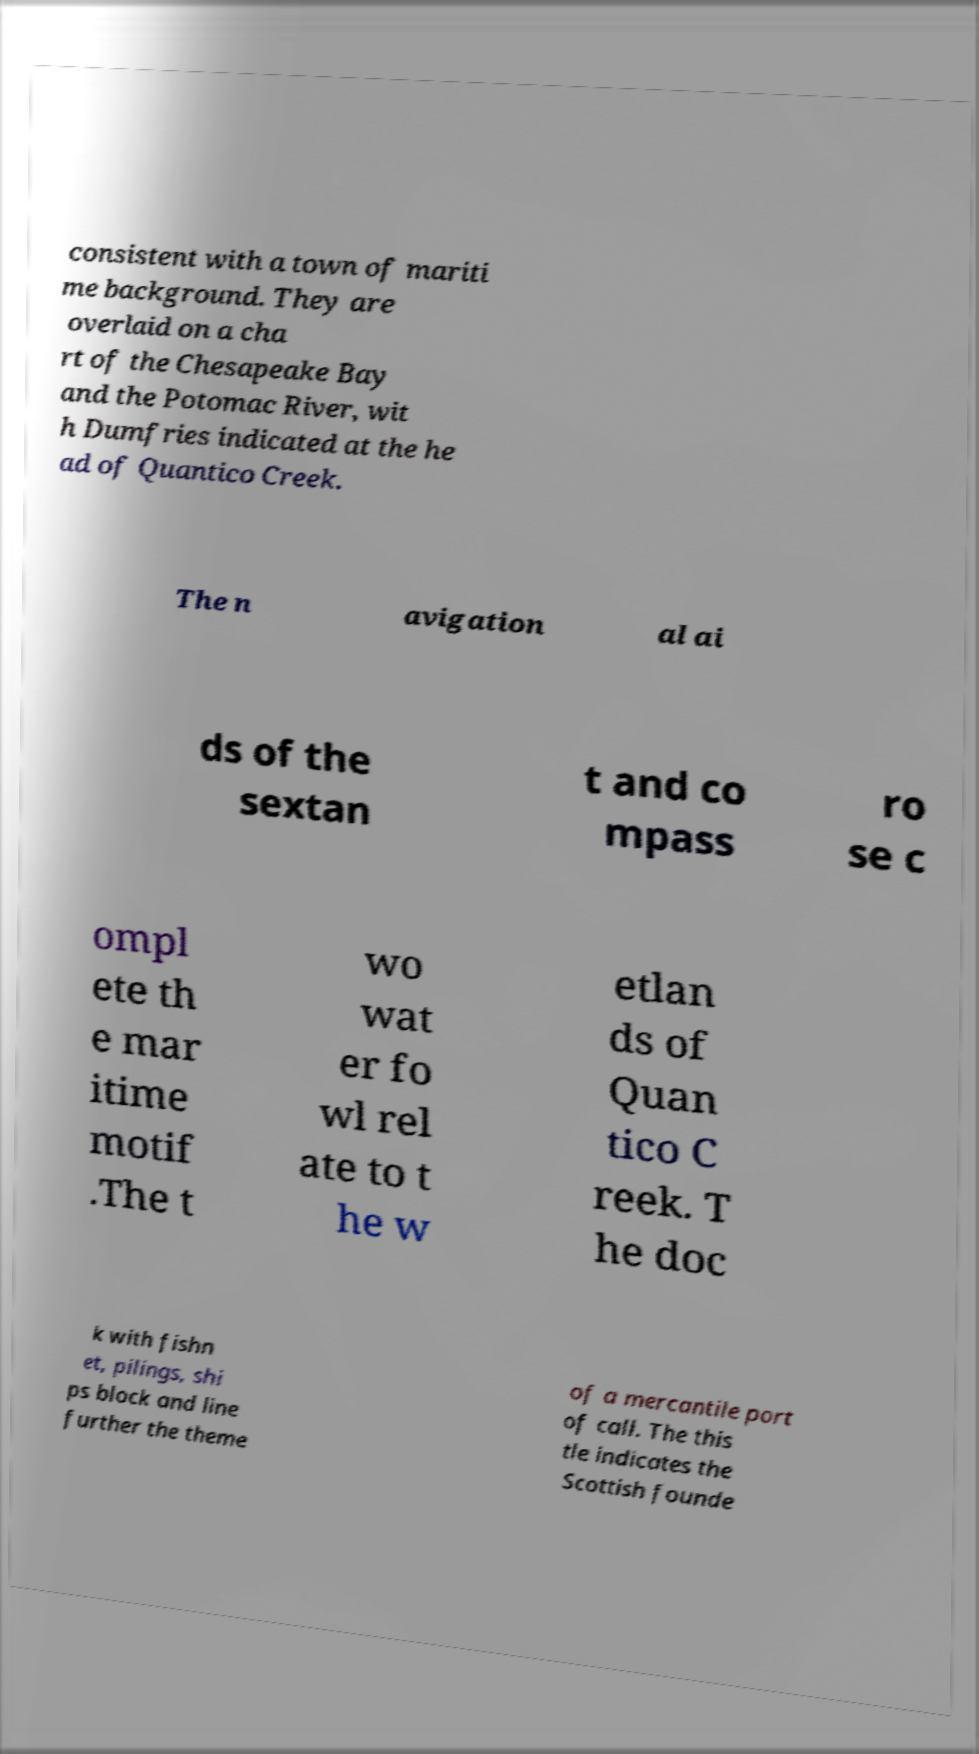What messages or text are displayed in this image? I need them in a readable, typed format. consistent with a town of mariti me background. They are overlaid on a cha rt of the Chesapeake Bay and the Potomac River, wit h Dumfries indicated at the he ad of Quantico Creek. The n avigation al ai ds of the sextan t and co mpass ro se c ompl ete th e mar itime motif .The t wo wat er fo wl rel ate to t he w etlan ds of Quan tico C reek. T he doc k with fishn et, pilings, shi ps block and line further the theme of a mercantile port of call. The this tle indicates the Scottish founde 